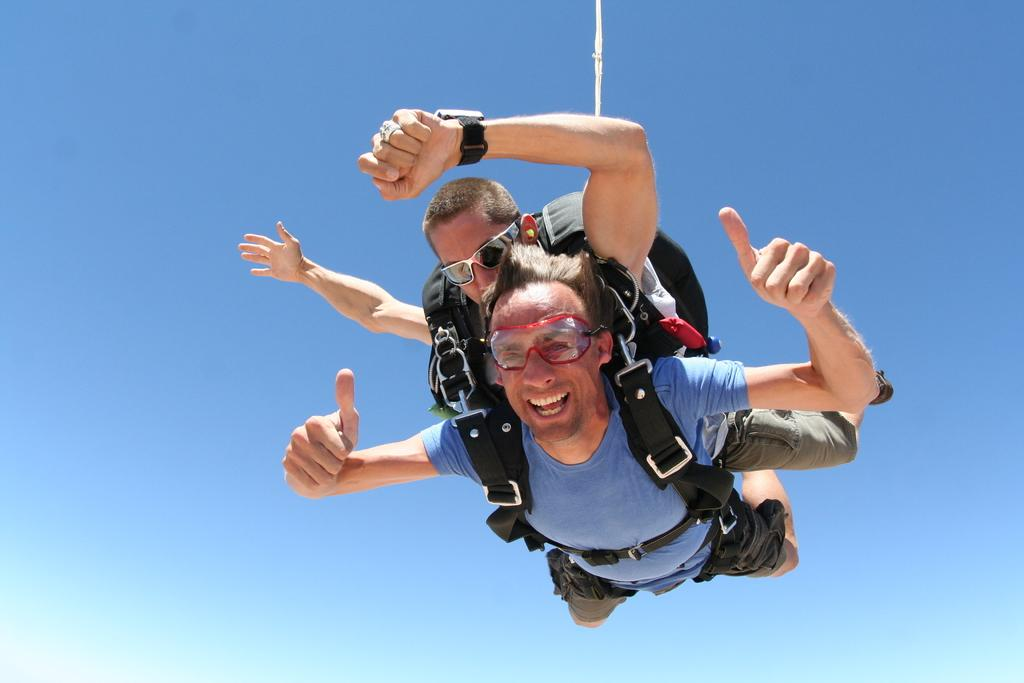How many people are in the image? There are two people in the image. What are the people doing in the image? The people are in the air. What can be seen in the background of the image? There is a blue sky in the background of the image. How does the lip affect the people in the image? There is no lip present in the image, so it cannot affect the people. 